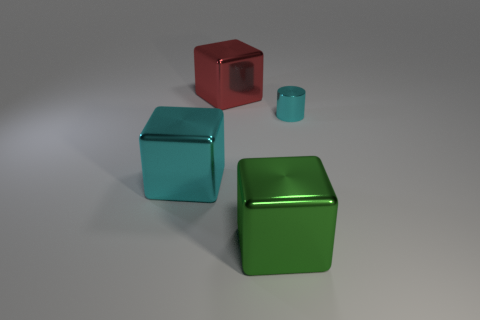What is the lighting like in this scene, and how does it affect the appearance of the objects? The lighting in the image is soft and diffuse, creating gentle shadows and subtle highlights that enhance the three-dimensional form of each object without causing harsh glare or overly dark shadows. 